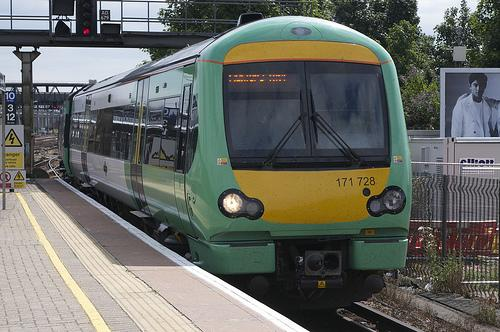Describe the platform near the train. The platform has a thin yellow stripe and is made of concrete stone bricks. Talk about the signage and the warnings visible in the image. There are yellow caution signs, a white and yellow electrical hazard warning, and a yellow and black triangle on a sign. Elaborate on a detail about the train's appearance. The train has a yellow face and features black wipers on its windshield. Mention the primary object in the picture along with its main features. A green and yellow train is standing on railroad tracks with many windows, numbers, and one headlight lit. Describe a feature of the train's windows. The train has a large window at the front with an orange digital destination display. Mention the elements related to the sidewalk in the picture. The sidewalk has a yellow line, a white curb, and a short black fence by the train. List the elements related to the train's headlights. One headlight is turned on, while the other is turned off; there's also a small red light above the train. Write a sentence about an advertisement in the image. There is a grey and white ad featuring a man in a white shirt on a nearby billboard. Point out something unique near the fence in the image. There is small green vegetation growing near the fence. Identify and describe the setting of the image. The scene takes place outdoors, with green trees in the background and a clear blue sky. 